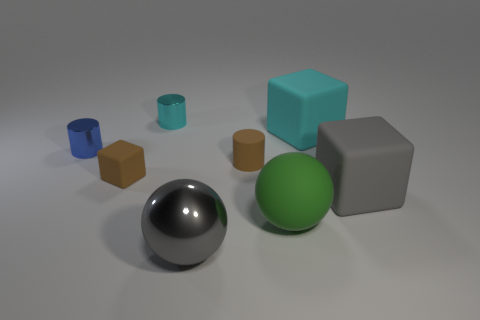Subtract all gray balls. How many balls are left? 1 Subtract all small cyan shiny cylinders. How many cylinders are left? 2 Add 4 tiny matte objects. How many tiny matte objects exist? 6 Add 1 large green rubber balls. How many objects exist? 9 Subtract 0 red spheres. How many objects are left? 8 Subtract all blocks. How many objects are left? 5 Subtract 1 balls. How many balls are left? 1 Subtract all green cylinders. Subtract all blue cubes. How many cylinders are left? 3 Subtract all cyan cubes. How many gray balls are left? 1 Subtract all objects. Subtract all big purple matte cubes. How many objects are left? 0 